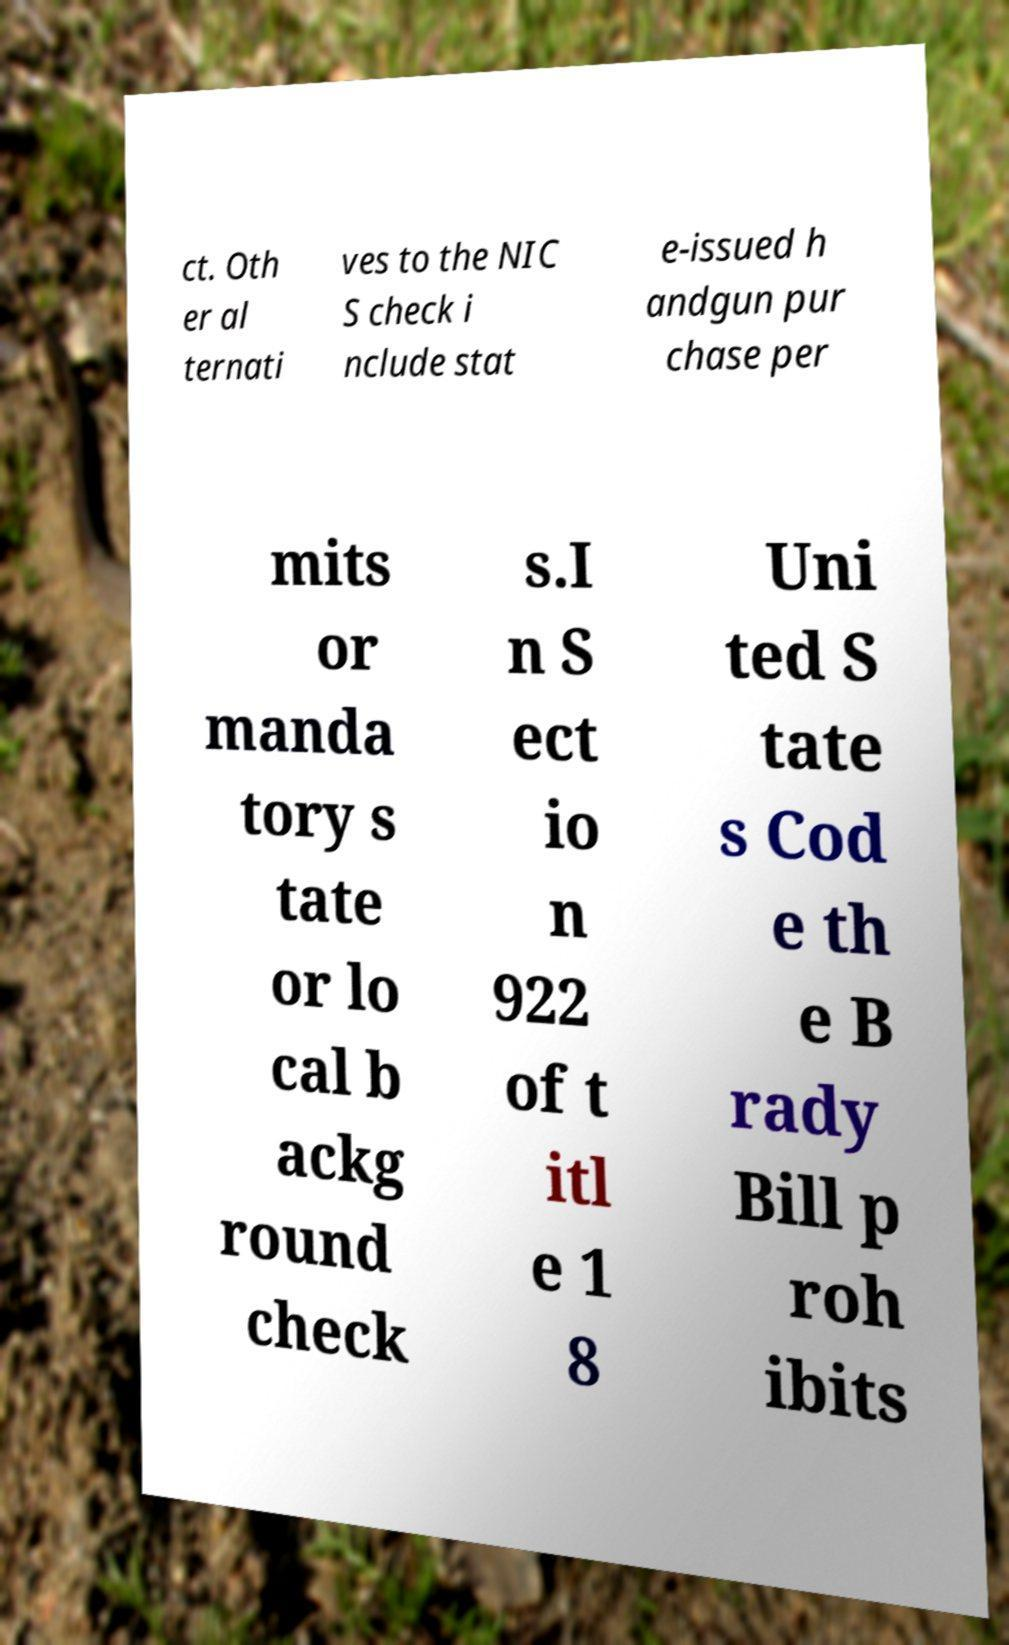I need the written content from this picture converted into text. Can you do that? ct. Oth er al ternati ves to the NIC S check i nclude stat e-issued h andgun pur chase per mits or manda tory s tate or lo cal b ackg round check s.I n S ect io n 922 of t itl e 1 8 Uni ted S tate s Cod e th e B rady Bill p roh ibits 